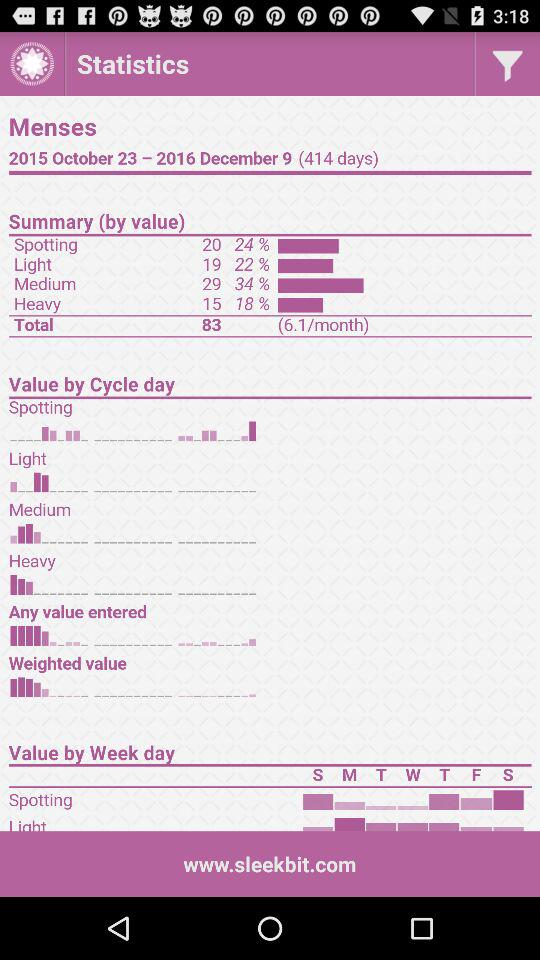What is the application name?
When the provided information is insufficient, respond with <no answer>. <no answer> 